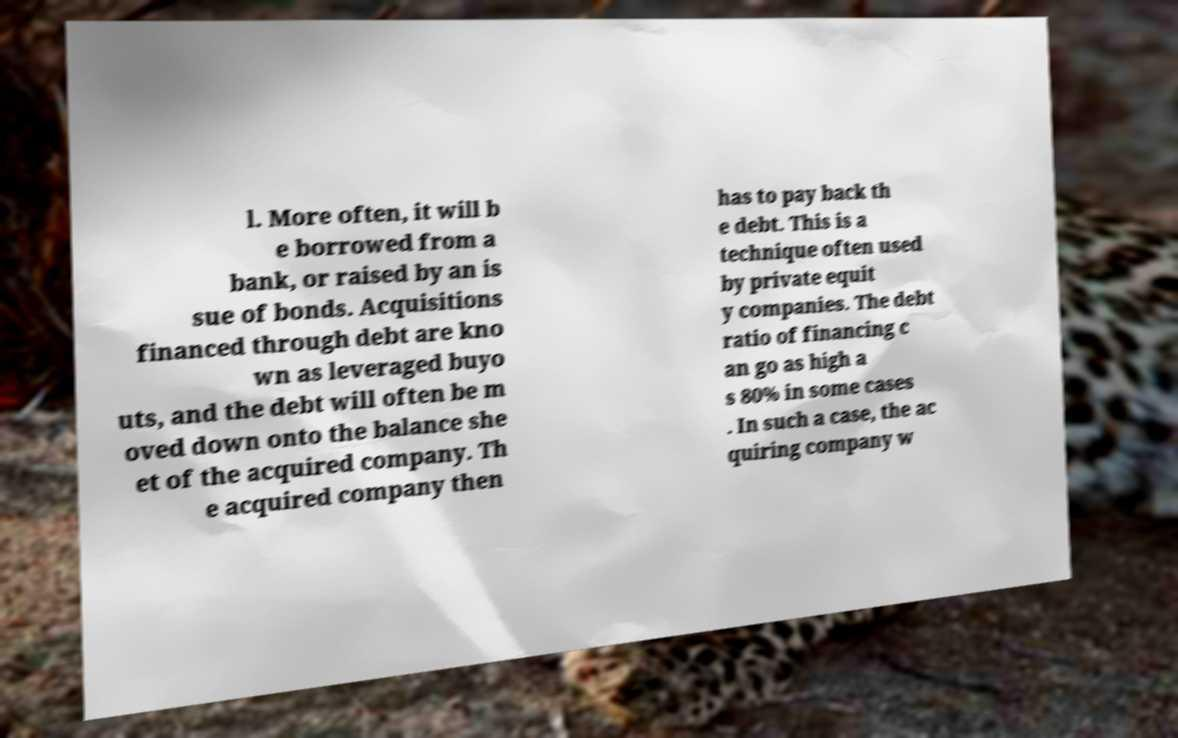There's text embedded in this image that I need extracted. Can you transcribe it verbatim? l. More often, it will b e borrowed from a bank, or raised by an is sue of bonds. Acquisitions financed through debt are kno wn as leveraged buyo uts, and the debt will often be m oved down onto the balance she et of the acquired company. Th e acquired company then has to pay back th e debt. This is a technique often used by private equit y companies. The debt ratio of financing c an go as high a s 80% in some cases . In such a case, the ac quiring company w 